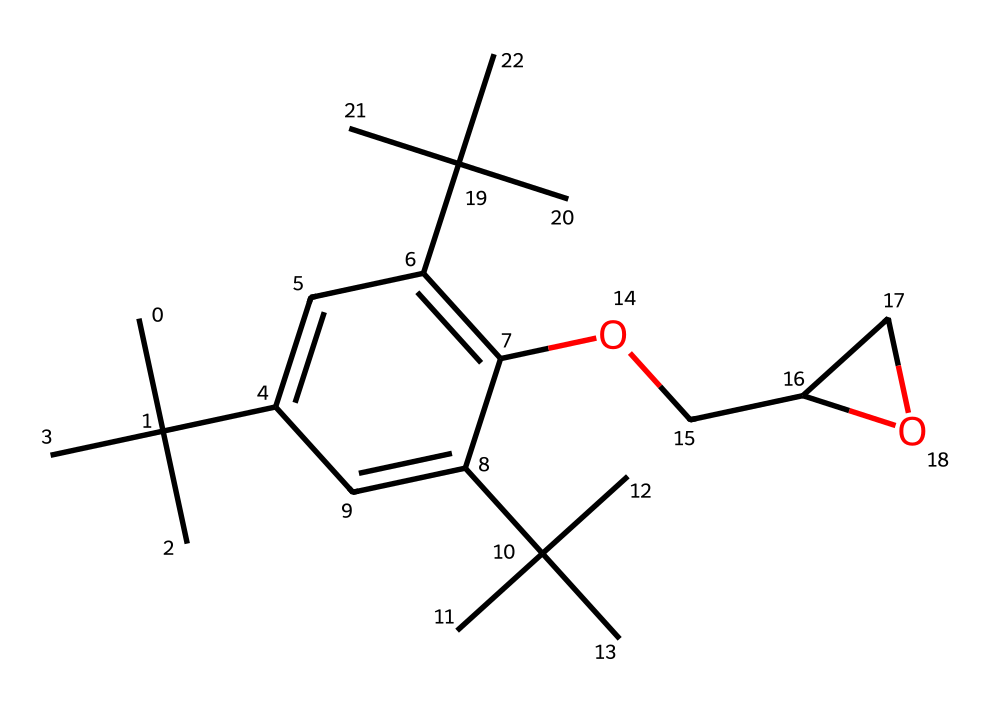What is the molecular weight of this chemical? To determine the molecular weight, count the atoms in the SMILES representation. By identifying the carbon, hydrogen, and oxygen atoms, calculate the total weight using molar masses: Carbon (C) is approximately 12.01 g/mol, Hydrogen (H) is about 1.008 g/mol, and Oxygen (O) is around 16.00 g/mol. After parsing the SMILES, the molecular weight totals to approximately 398.56 g/mol.
Answer: 398.56 g/mol How many ring structures are present in this compound? Analyzing the SMILES structure reveals the presence of a cyclic component. By identifying the "C1" and "C" notation, which denotes a ring formation, we can see that there is one ring in this structure, specifically a phenolic ring.
Answer: 1 What functional groups are present in this chemical? The SMILES indicates various functional groups, including an ether (-O-) and a phenolic hydroxyl (-OH) group. By interpreting the functional groups from the chemical structure, we conclude that both ether and hydroxyl groups are present.
Answer: ether and hydroxyl How many carbon atoms does this chemical contain? By counting each 'C' in the SMILES and considering branching indicated by parentheses, a total of 28 carbon atoms can be counted within the structure.
Answer: 28 Is this chemical a polymer or a monomer? Given its structural complexity with branching and the presence of epoxy resins, this chemical behaves as a polymer precursor, suggesting it is likely a monomer used in the polymerization process.
Answer: monomer What type of photoresist does this chemical represent? Evaluating the epoxy functionality along with its negative-tone characteristics suggests it fits within the category of chemically amplified photoresists. Therefore, it can be classified as a negative-tone chemically amplified photoresist.
Answer: negative-tone chemically amplified photoresist 